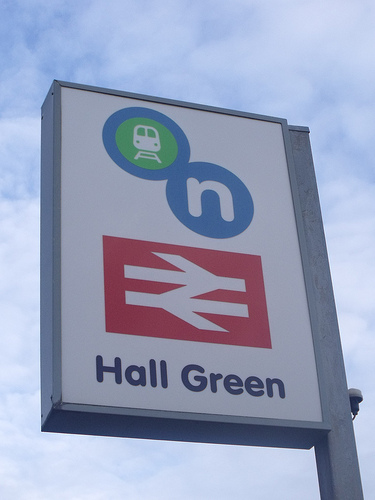<image>
Is the clouds in front of the sign? No. The clouds is not in front of the sign. The spatial positioning shows a different relationship between these objects. 